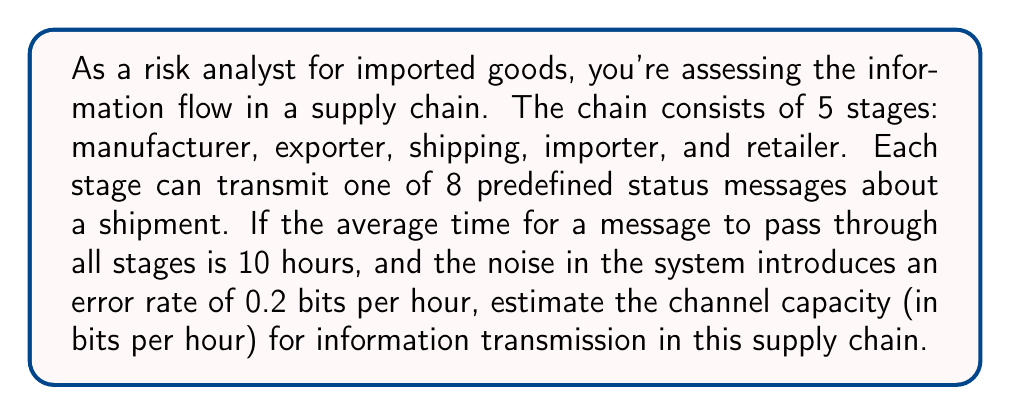Provide a solution to this math problem. To solve this problem, we'll use the Shannon-Hartley theorem, which relates channel capacity to bandwidth and signal-to-noise ratio. However, we need to adapt it to our discrete, time-based scenario.

1. First, let's calculate the maximum information content per message:
   With 8 possible messages, we have $\log_2(8) = 3$ bits per message.

2. The total information transmitted through the chain:
   $I_{total} = 5 \text{ stages} \times 3 \text{ bits/message} = 15 \text{ bits}$

3. Time taken for transmission:
   Given as 10 hours for the entire chain.

4. Information rate without noise:
   $R = \frac{I_{total}}{T} = \frac{15 \text{ bits}}{10 \text{ hours}} = 1.5 \text{ bits/hour}$

5. Noise in the system:
   0.2 bits per hour

6. To calculate the channel capacity, we need to subtract the noise from the information rate:
   $C = R - N = 1.5 \text{ bits/hour} - 0.2 \text{ bits/hour} = 1.3 \text{ bits/hour}$

This result represents the maximum rate at which information can be reliably transmitted through the supply chain, accounting for the noise in the system.
Answer: The estimated channel capacity for information transmission in the supply chain is 1.3 bits per hour. 